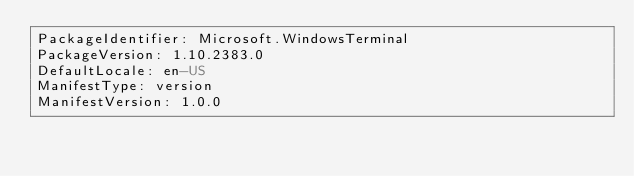Convert code to text. <code><loc_0><loc_0><loc_500><loc_500><_YAML_>PackageIdentifier: Microsoft.WindowsTerminal
PackageVersion: 1.10.2383.0
DefaultLocale: en-US
ManifestType: version
ManifestVersion: 1.0.0

</code> 